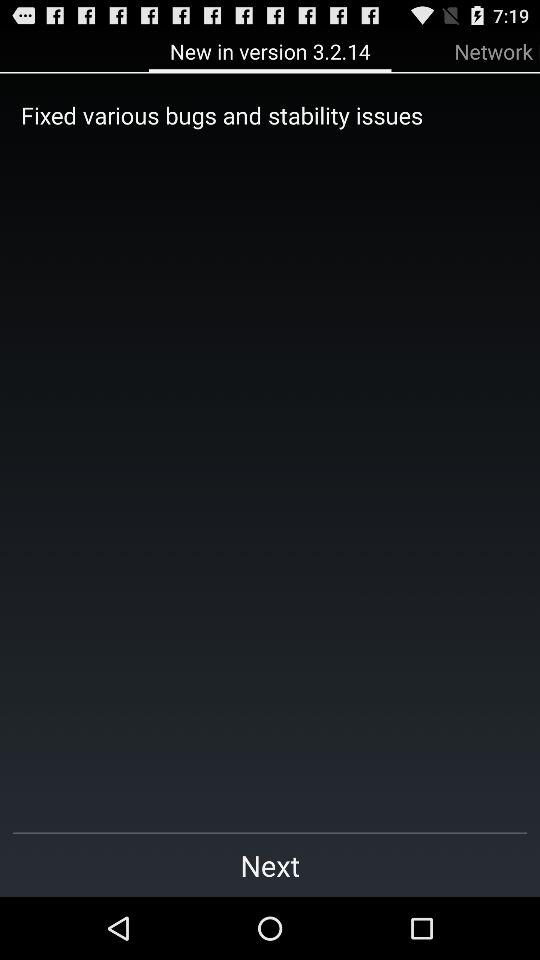What is in the new version? The new version comprises "Fixed various bugs and stability issues". 